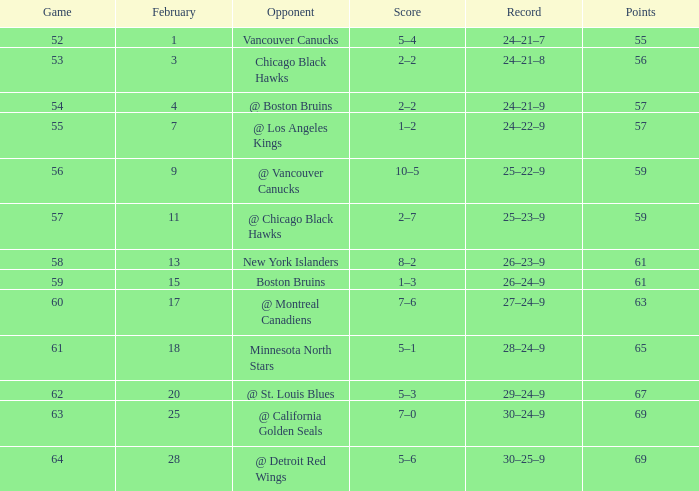Which opponent has a game larger than 61, february smaller than 28, and fewer points than 69? @ St. Louis Blues. 